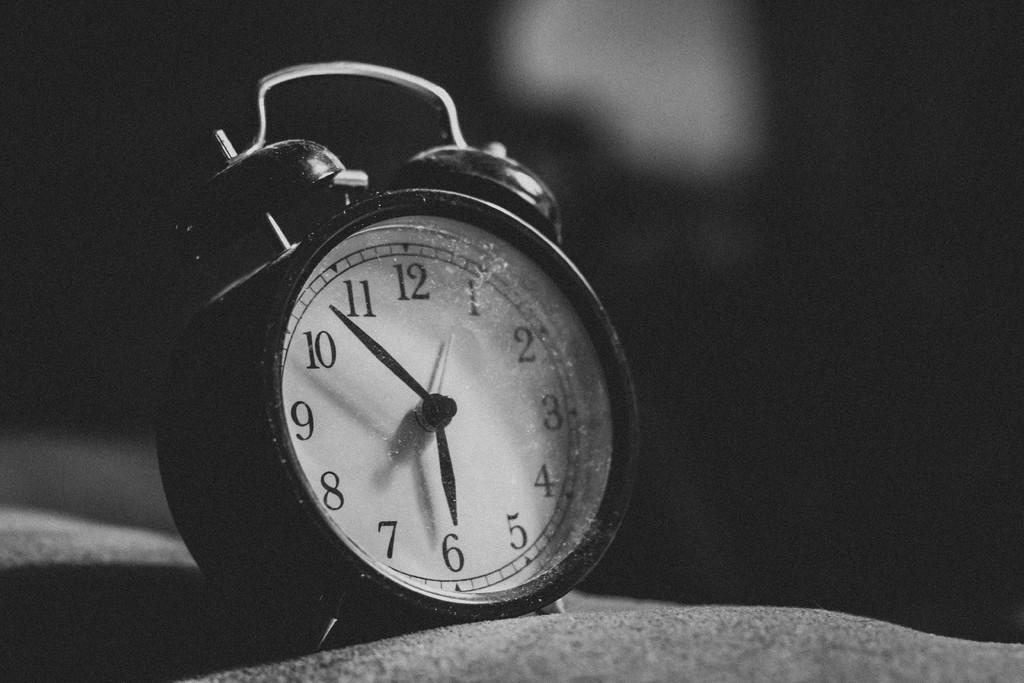What color is the clock in the image? The clock is white in color. What is the overall color scheme of the image? The image is black and white. What object can be seen in the image that is used for telling time? There is a clock in the image. Can you see a fight between two cats in the image? There is no fight or cats present in the image; it only features a white clock. 